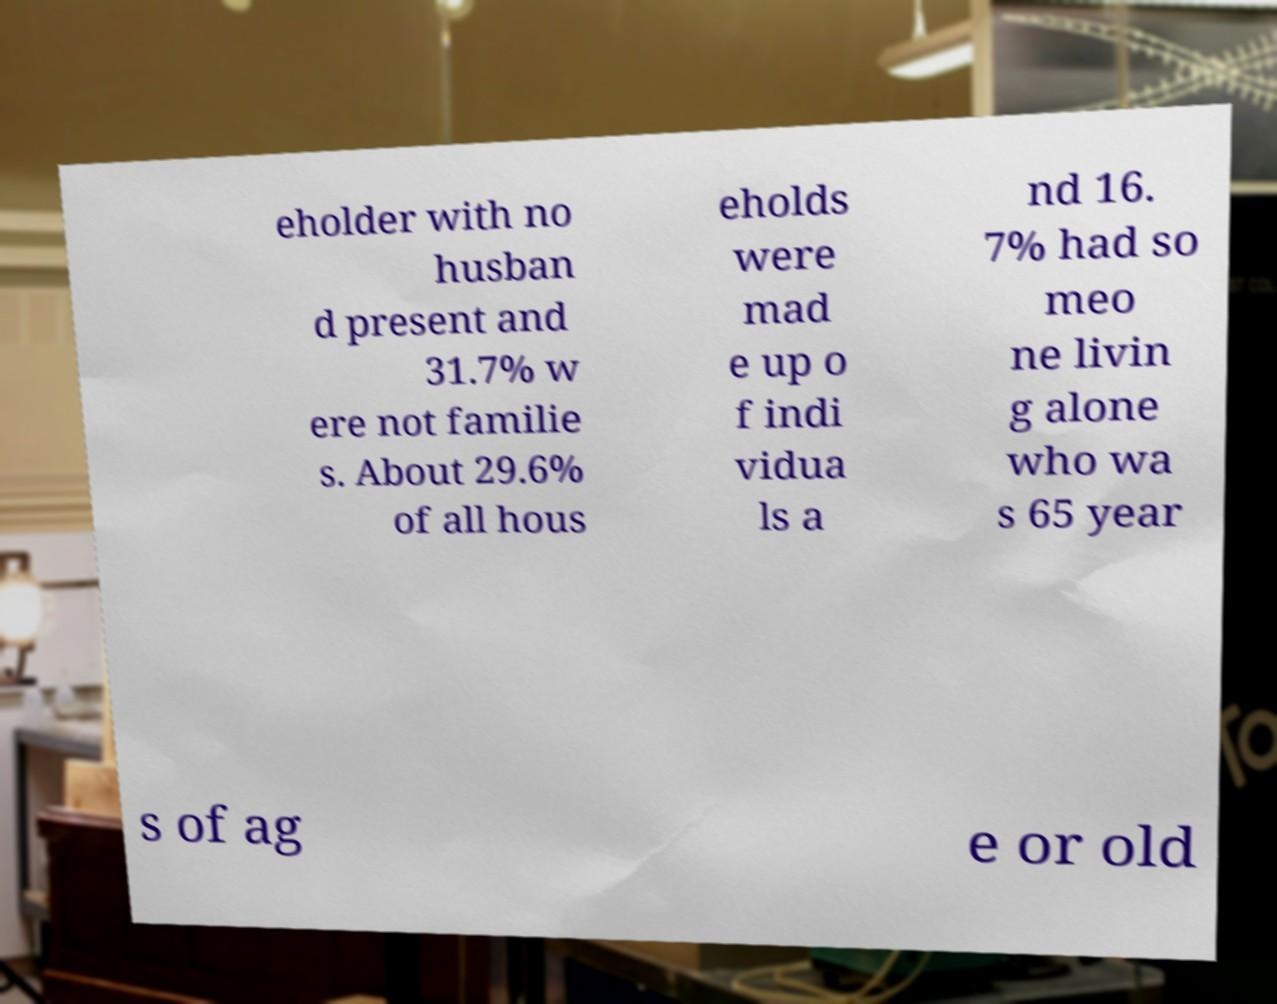I need the written content from this picture converted into text. Can you do that? eholder with no husban d present and 31.7% w ere not familie s. About 29.6% of all hous eholds were mad e up o f indi vidua ls a nd 16. 7% had so meo ne livin g alone who wa s 65 year s of ag e or old 